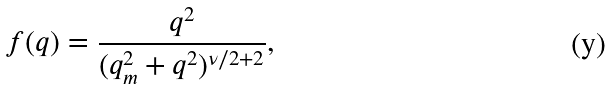<formula> <loc_0><loc_0><loc_500><loc_500>f ( { q } ) = \frac { q ^ { 2 } } { ( q _ { m } ^ { 2 } + q ^ { 2 } ) ^ { \nu / 2 + 2 } } ,</formula> 